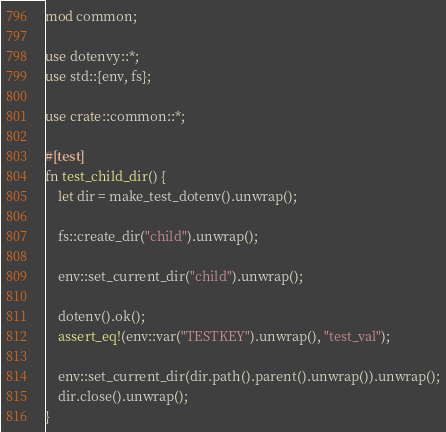Convert code to text. <code><loc_0><loc_0><loc_500><loc_500><_Rust_>mod common;

use dotenvy::*;
use std::{env, fs};

use crate::common::*;

#[test]
fn test_child_dir() {
    let dir = make_test_dotenv().unwrap();

    fs::create_dir("child").unwrap();

    env::set_current_dir("child").unwrap();

    dotenv().ok();
    assert_eq!(env::var("TESTKEY").unwrap(), "test_val");

    env::set_current_dir(dir.path().parent().unwrap()).unwrap();
    dir.close().unwrap();
}
</code> 